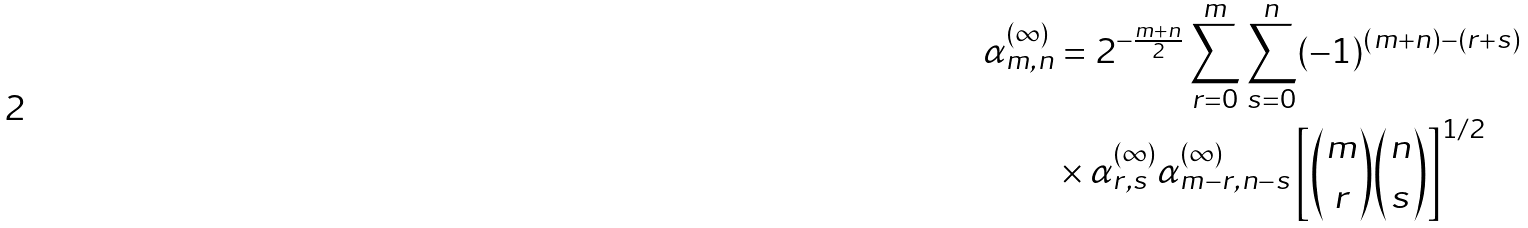Convert formula to latex. <formula><loc_0><loc_0><loc_500><loc_500>\alpha _ { m , n } ^ { ( \infty ) } & = 2 ^ { - \frac { m + n } { 2 } } \sum _ { r = 0 } ^ { m } \sum _ { s = 0 } ^ { n } ( - 1 ) ^ { ( m + n ) - ( r + s ) } \\ & \times \alpha _ { r , s } ^ { ( \infty ) } \alpha _ { m - r , n - s } ^ { ( \infty ) } \left [ { { m \choose r } { n \choose s } } \right ] ^ { 1 / 2 }</formula> 